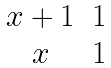<formula> <loc_0><loc_0><loc_500><loc_500>\begin{matrix} x + 1 & 1 \\ x & 1 \end{matrix}</formula> 